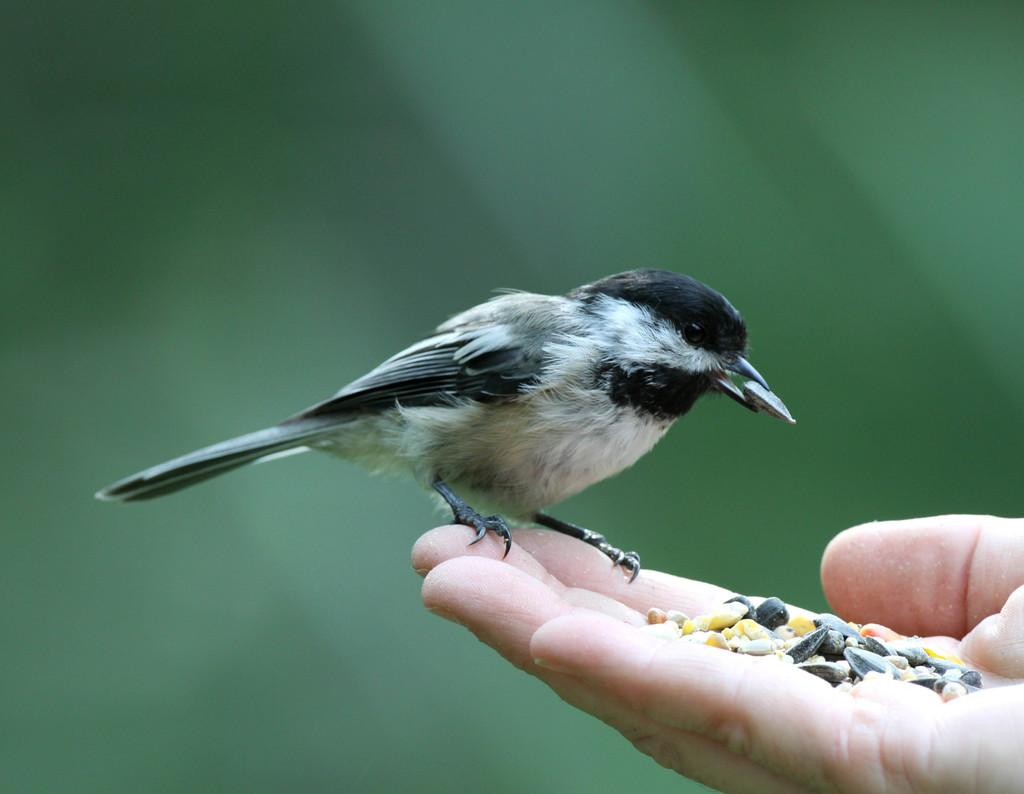What type of animal can be seen in the image? There is a bird in the image. What is the bird doing in the image? The bird is standing on a hand. What is in the hand that the bird is standing on? There are grains in the hand. Can you describe the background of the image? The background of the image is blurry. How does the bird's father react to the earthquake in the image? There is no father or earthquake present in the image; it features a bird standing on a hand with grains. 